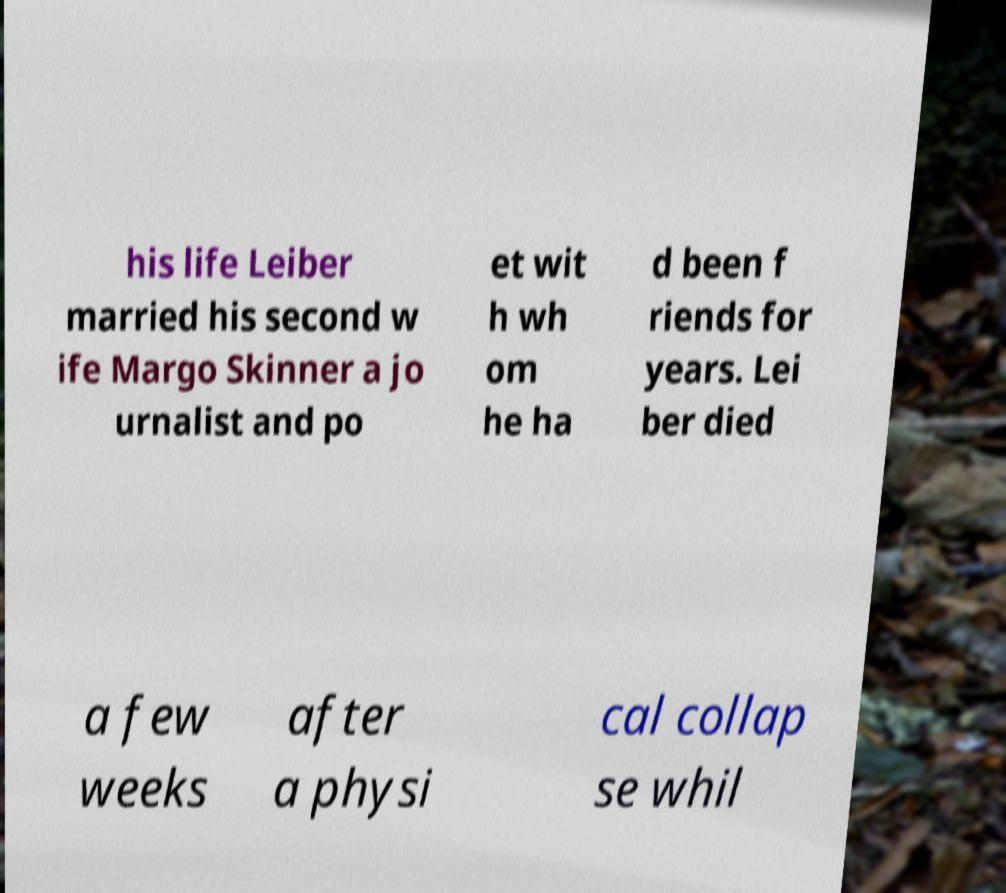Could you extract and type out the text from this image? his life Leiber married his second w ife Margo Skinner a jo urnalist and po et wit h wh om he ha d been f riends for years. Lei ber died a few weeks after a physi cal collap se whil 